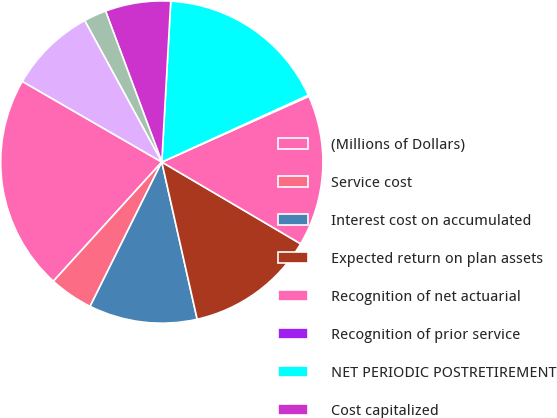<chart> <loc_0><loc_0><loc_500><loc_500><pie_chart><fcel>(Millions of Dollars)<fcel>Service cost<fcel>Interest cost on accumulated<fcel>Expected return on plan assets<fcel>Recognition of net actuarial<fcel>Recognition of prior service<fcel>NET PERIODIC POSTRETIREMENT<fcel>Cost capitalized<fcel>Reconciliation to rate level<fcel>Cost charged to operating<nl><fcel>21.6%<fcel>4.41%<fcel>10.86%<fcel>13.01%<fcel>15.16%<fcel>0.12%<fcel>17.3%<fcel>6.56%<fcel>2.27%<fcel>8.71%<nl></chart> 